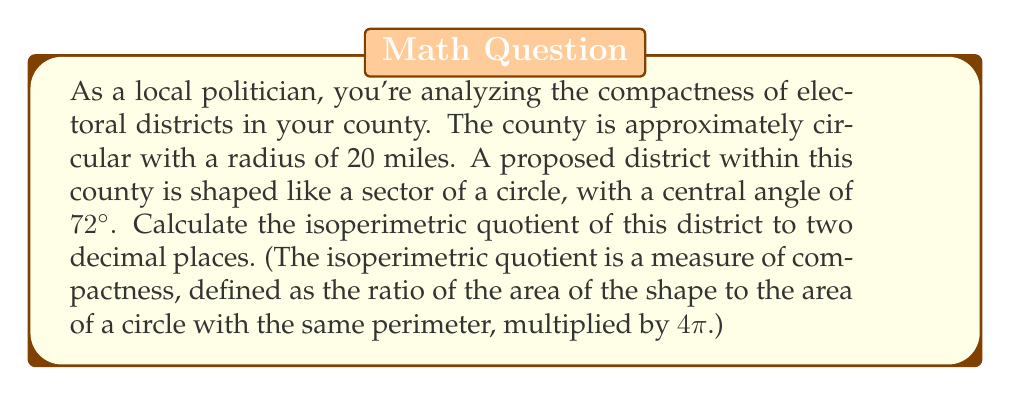Can you solve this math problem? To solve this problem, we'll follow these steps:

1) First, let's calculate the area of the sector:
   Area of sector = $\frac{\theta}{360°} \pi r^2$, where $\theta$ is the central angle in degrees
   $$A = \frac{72}{360} \pi (20)^2 = 4\pi(20)^2 = 1600\pi \text{ sq miles}$$

2) Next, we need to find the perimeter of the sector. It consists of two radii and an arc:
   Perimeter = 2r + arc length
   Arc length = $\frac{\theta}{360°} 2\pi r$
   $$P = 2(20) + \frac{72}{360} 2\pi(20) = 40 + 8\pi \text{ miles}$$

3) The isoperimetric quotient (IQ) is defined as:
   $$IQ = \frac{4\pi A}{P^2}$$

4) Substituting our values:
   $$IQ = \frac{4\pi(1600\pi)}{(40 + 8\pi)^2}$$

5) Simplifying:
   $$IQ = \frac{6400\pi^2}{1600 + 640\pi + 64\pi^2}$$

6) Using a calculator to evaluate this (as it's not easily simplifiable), we get:
   $$IQ \approx 0.7234$$

7) Rounding to two decimal places:
   $$IQ \approx 0.72$$

This value indicates that the district is reasonably compact, as it's closer to 1 (which would represent a perfect circle) than to 0.
Answer: 0.72 